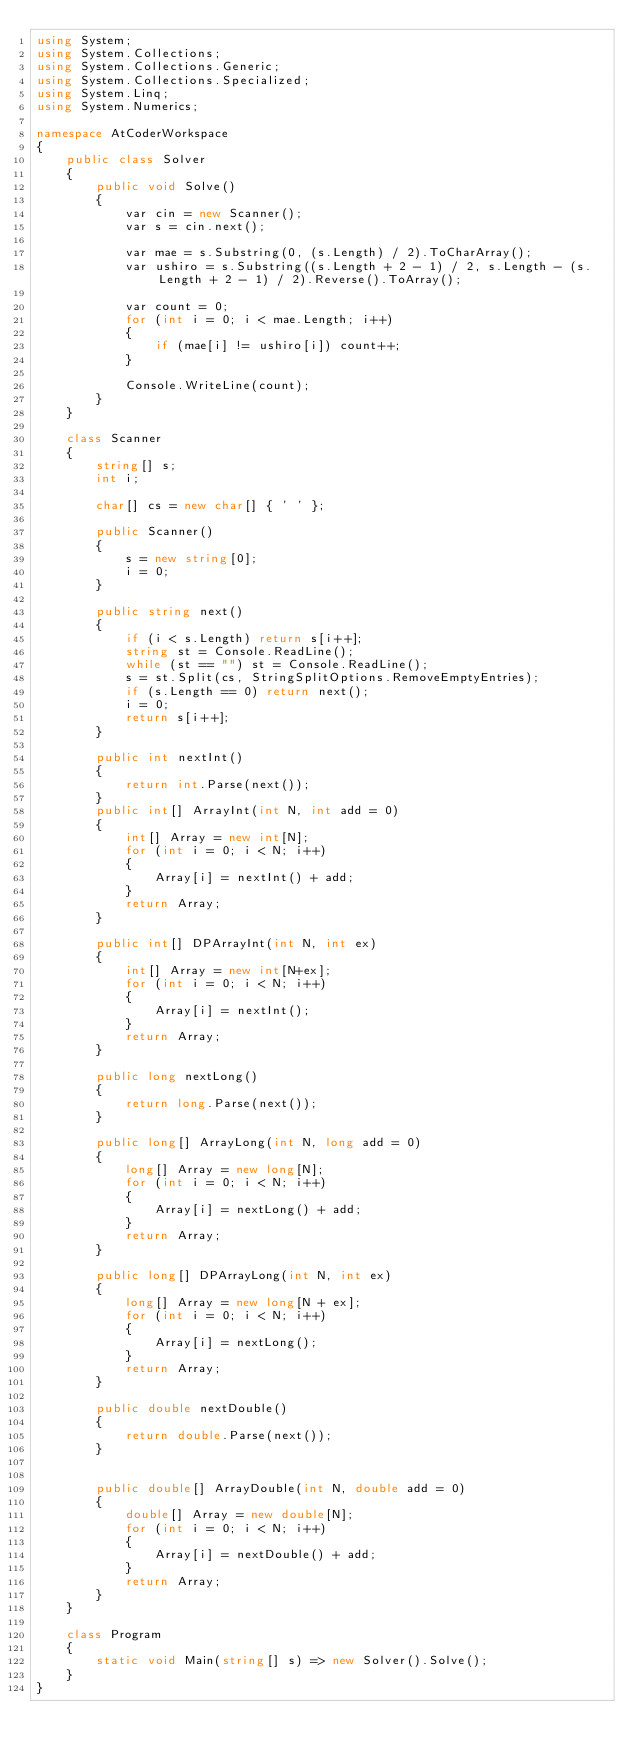<code> <loc_0><loc_0><loc_500><loc_500><_C#_>using System;
using System.Collections;
using System.Collections.Generic;
using System.Collections.Specialized;
using System.Linq;
using System.Numerics;

namespace AtCoderWorkspace
{
    public class Solver
    {
        public void Solve()
        {
            var cin = new Scanner();
            var s = cin.next();
                        
            var mae = s.Substring(0, (s.Length) / 2).ToCharArray();
            var ushiro = s.Substring((s.Length + 2 - 1) / 2, s.Length - (s.Length + 2 - 1) / 2).Reverse().ToArray();

            var count = 0;
            for (int i = 0; i < mae.Length; i++)
            {
                if (mae[i] != ushiro[i]) count++;
            }

            Console.WriteLine(count);
        }
    }

    class Scanner
    {
        string[] s;
        int i;

        char[] cs = new char[] { ' ' };

        public Scanner()
        {
            s = new string[0];
            i = 0;
        }

        public string next()
        {
            if (i < s.Length) return s[i++];
            string st = Console.ReadLine();
            while (st == "") st = Console.ReadLine();
            s = st.Split(cs, StringSplitOptions.RemoveEmptyEntries);
            if (s.Length == 0) return next();
            i = 0;
            return s[i++];
        }

        public int nextInt()
        {
            return int.Parse(next());
        }
        public int[] ArrayInt(int N, int add = 0)
        {
            int[] Array = new int[N];
            for (int i = 0; i < N; i++)
            {
                Array[i] = nextInt() + add;
            }
            return Array;
        }

        public int[] DPArrayInt(int N, int ex)
        {
            int[] Array = new int[N+ex];
            for (int i = 0; i < N; i++)
            {
                Array[i] = nextInt();
            }
            return Array;
        }

        public long nextLong()
        {
            return long.Parse(next());
        }

        public long[] ArrayLong(int N, long add = 0)
        {
            long[] Array = new long[N];
            for (int i = 0; i < N; i++)
            {
                Array[i] = nextLong() + add;
            }
            return Array;
        }

        public long[] DPArrayLong(int N, int ex)
        {
            long[] Array = new long[N + ex];
            for (int i = 0; i < N; i++)
            {
                Array[i] = nextLong();
            }
            return Array;
        }

        public double nextDouble()
        {
            return double.Parse(next());
        }


        public double[] ArrayDouble(int N, double add = 0)
        {
            double[] Array = new double[N];
            for (int i = 0; i < N; i++)
            {
                Array[i] = nextDouble() + add;
            }
            return Array;
        }
    }   

    class Program
    {
        static void Main(string[] s) => new Solver().Solve();
    }
}
</code> 